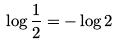<formula> <loc_0><loc_0><loc_500><loc_500>\log \frac { 1 } { 2 } = - \log 2</formula> 